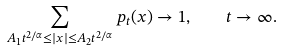<formula> <loc_0><loc_0><loc_500><loc_500>\sum _ { A _ { 1 } t ^ { 2 / \alpha } \leq | x | \leq A _ { 2 } t ^ { 2 / \alpha } } p _ { t } ( x ) \to 1 , \quad t \to \infty .</formula> 